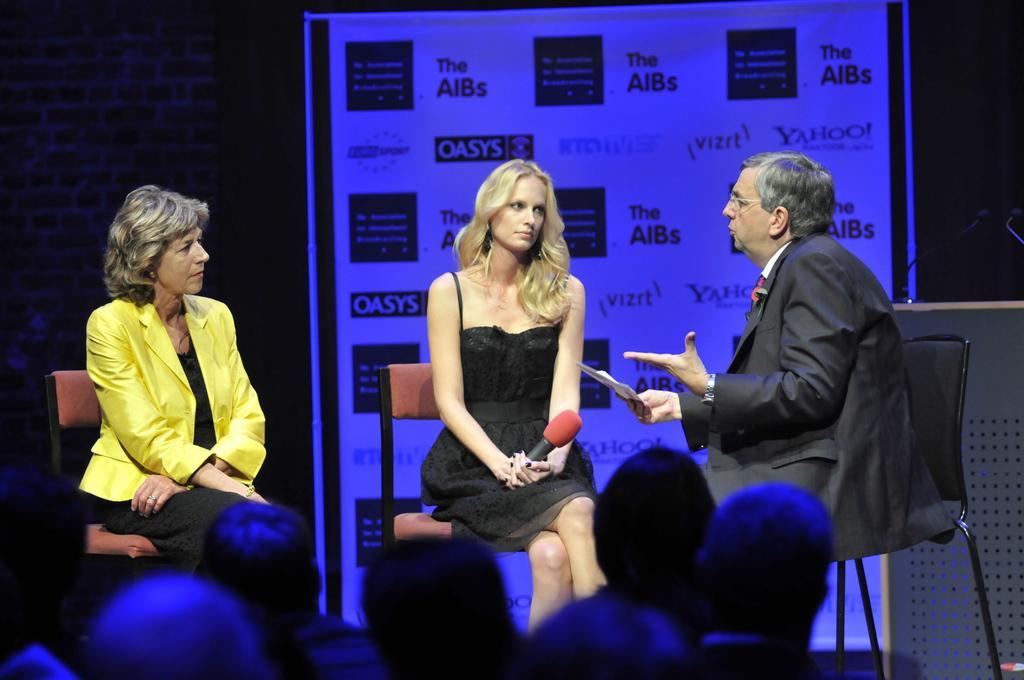Can you describe this image briefly? In this picture there is a man sitting and talking and he is holding the paper. There is a woman with black dress is sitting and holding the microphone and there is a woman with yellow jacket is sitting. At the back there is a hoarding and there is text on the hoarding. In the foreground there are group of people sitting. At the back there is wall. On the right side of the image there are microphones on the podium. 